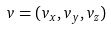Convert formula to latex. <formula><loc_0><loc_0><loc_500><loc_500>v = ( v _ { x } , v _ { y } , v _ { z } )</formula> 